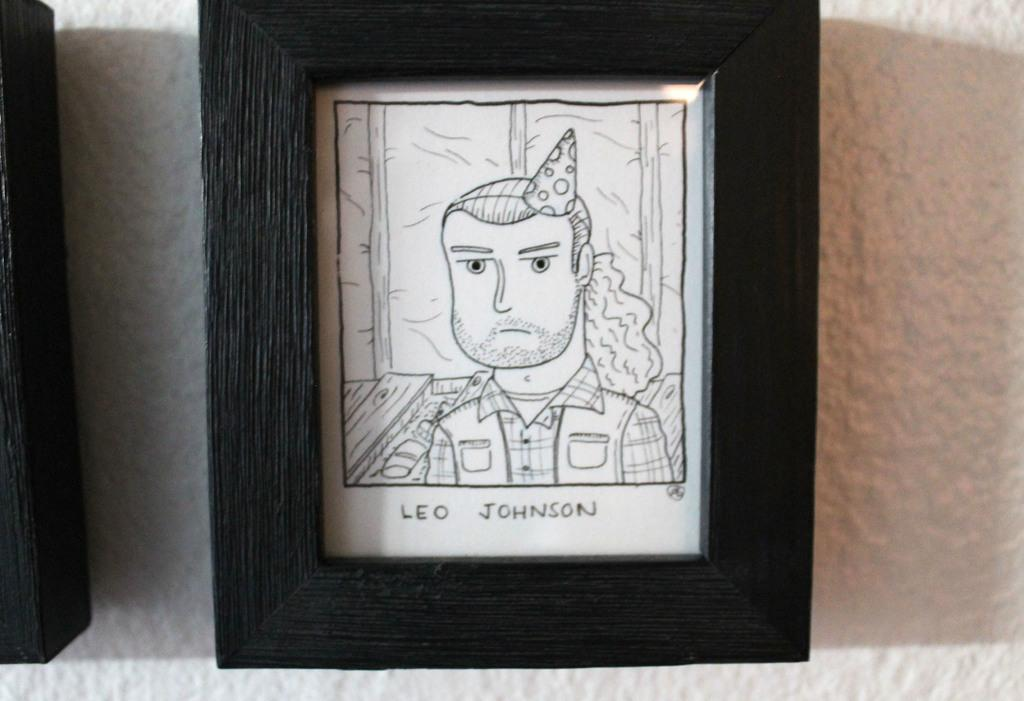<image>
Share a concise interpretation of the image provided. A framed drawing of a man says, "Leo Johnson" under it. 